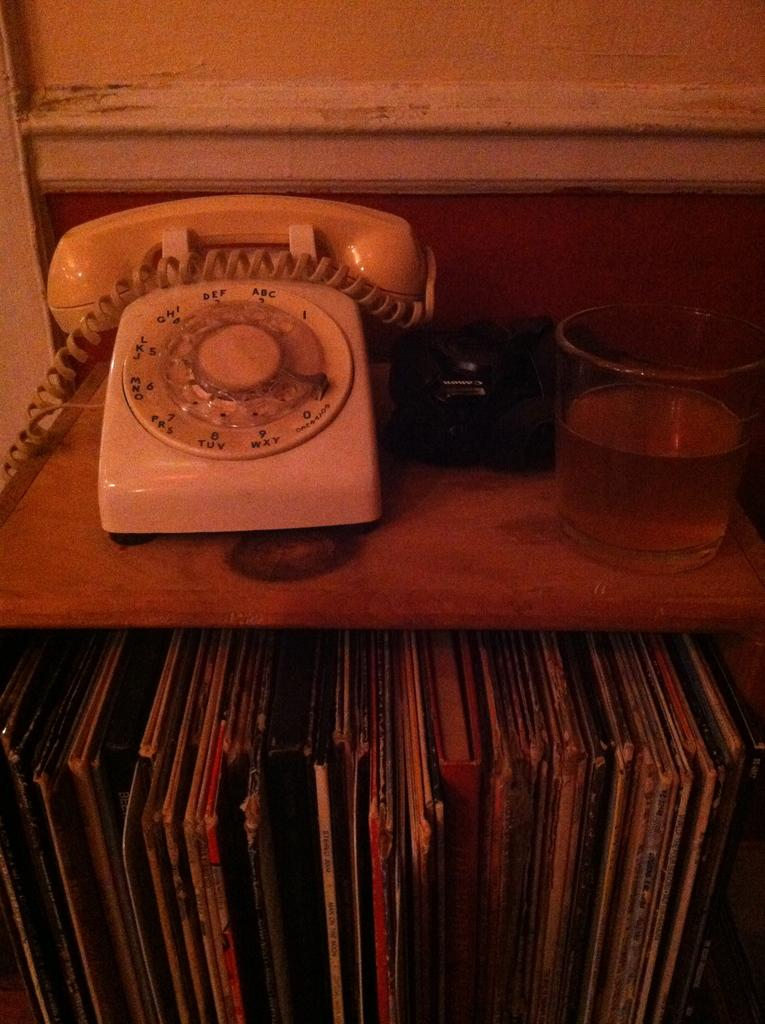<image>
Offer a succinct explanation of the picture presented. a phone that has abc written on it 